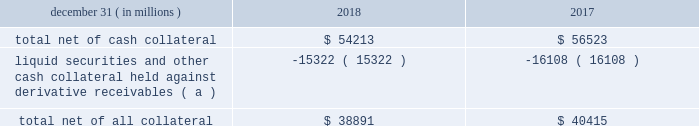Jpmorgan chase & co./2018 form 10-k 117 lending-related commitments the firm uses lending-related financial instruments , such as commitments ( including revolving credit facilities ) and guarantees , to address the financing needs of its clients .
The contractual amounts of these financial instruments represent the maximum possible credit risk should the clients draw down on these commitments or the firm fulfill its obligations under these guarantees , and the clients subsequently fail to perform according to the terms of these contracts .
Most of these commitments and guarantees are refinanced , extended , cancelled , or expire without being drawn upon or a default occurring .
In the firm 2019s view , the total contractual amount of these wholesale lending-related commitments is not representative of the firm 2019s expected future credit exposure or funding requirements .
For further information on wholesale lending-related commitments , refer to note 27 .
Clearing services the firm provides clearing services for clients entering into certain securities and derivative contracts .
Through the provision of these services the firm is exposed to the risk of non-performance by its clients and may be required to share in losses incurred by ccps .
Where possible , the firm seeks to mitigate its credit risk to its clients through the collection of adequate margin at inception and throughout the life of the transactions and can also cease provision of clearing services if clients do not adhere to their obligations under the clearing agreement .
For further discussion of clearing services , refer to note 27 .
Derivative contracts derivatives enable clients and counterparties to manage risks including credit risk and risks arising from fluctuations in interest rates , foreign exchange , equities , and commodities .
The firm makes markets in derivatives in order to meet these needs and uses derivatives to manage certain risks associated with net open risk positions from its market-making activities , including the counterparty credit risk arising from derivative receivables .
The firm also uses derivative instruments to manage its own credit and other market risk exposure .
The nature of the counterparty and the settlement mechanism of the derivative affect the credit risk to which the firm is exposed .
For otc derivatives the firm is exposed to the credit risk of the derivative counterparty .
For exchange-traded derivatives ( 201cetd 201d ) , such as futures and options , and 201ccleared 201d over-the-counter ( 201cotc-cleared 201d ) derivatives , the firm is generally exposed to the credit risk of the relevant ccp .
Where possible , the firm seeks to mitigate its credit risk exposures arising from derivative contracts through the use of legally enforceable master netting arrangements and collateral agreements .
For a further discussion of derivative contracts , counterparties and settlement types , refer to note 5 .
The table summarizes the net derivative receivables for the periods presented .
Derivative receivables .
( a ) includes collateral related to derivative instruments where appropriate legal opinions have not been either sought or obtained with respect to master netting agreements .
The fair value of derivative receivables reported on the consolidated balance sheets were $ 54.2 billion and $ 56.5 billion at december 31 , 2018 and 2017 , respectively .
Derivative receivables represent the fair value of the derivative contracts after giving effect to legally enforceable master netting agreements and cash collateral held by the firm .
However , in management 2019s view , the appropriate measure of current credit risk should also take into consideration additional liquid securities ( primarily u.s .
Government and agency securities and other group of seven nations ( 201cg7 201d ) government securities ) and other cash collateral held by the firm aggregating $ 15.3 billion and $ 16.1 billion at december 31 , 2018 and 2017 , respectively , that may be used as security when the fair value of the client 2019s exposure is in the firm 2019s favor .
In addition to the collateral described in the preceding paragraph , the firm also holds additional collateral ( primarily cash , g7 government securities , other liquid government-agency and guaranteed securities , and corporate debt and equity securities ) delivered by clients at the initiation of transactions , as well as collateral related to contracts that have a non-daily call frequency and collateral that the firm has agreed to return but has not yet settled as of the reporting date .
Although this collateral does not reduce the balances and is not included in the table above , it is available as security against potential exposure that could arise should the fair value of the client 2019s derivative contracts move in the firm 2019s favor .
The derivative receivables fair value , net of all collateral , also does not include other credit enhancements , such as letters of credit .
For additional information on the firm 2019s use of collateral agreements , refer to note 5 .
While useful as a current view of credit exposure , the net fair value of the derivative receivables does not capture the potential future variability of that credit exposure .
To capture the potential future variability of credit exposure , the firm calculates , on a client-by-client basis , three measures of potential derivatives-related credit loss : peak , derivative risk equivalent ( 201cdre 201d ) , and average exposure ( 201cavg 201d ) .
These measures all incorporate netting and collateral benefits , where applicable .
Peak represents a conservative measure of potential exposure to a counterparty calculated in a manner that is broadly equivalent to a 97.5% ( 97.5 % ) confidence level over the life of the transaction .
Peak is the primary measure used by the firm for setting of credit limits for derivative contracts , senior management reporting and derivatives exposure management .
Dre exposure is a measure that expresses the risk of derivative exposure on a basis intended to be .
What was the average balance of cash collateral for 2017 and 2018? 
Computations: ((((15.3 + 16.1) / 2) * 1000000) * 1000)
Answer: 15700000000.0. 